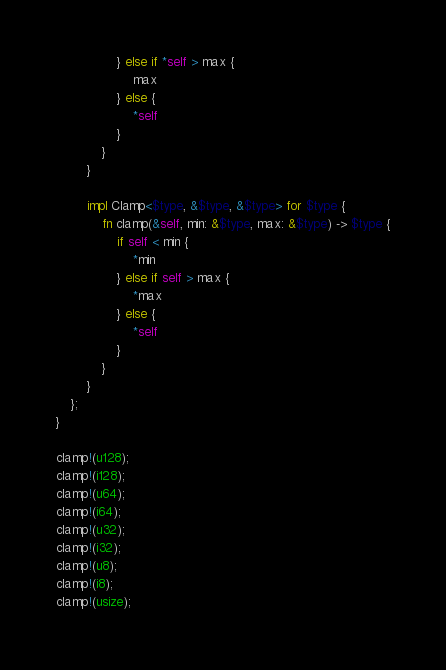Convert code to text. <code><loc_0><loc_0><loc_500><loc_500><_Rust_>                } else if *self > max {
                    max
                } else {
                    *self
                }
            }
        }

        impl Clamp<$type, &$type, &$type> for $type {
            fn clamp(&self, min: &$type, max: &$type) -> $type {
                if self < min {
                    *min
                } else if self > max {
                    *max
                } else {
                    *self
                }
            }
        }
    };
}

clamp!(u128);
clamp!(i128);
clamp!(u64);
clamp!(i64);
clamp!(u32);
clamp!(i32);
clamp!(u8);
clamp!(i8);
clamp!(usize);
</code> 